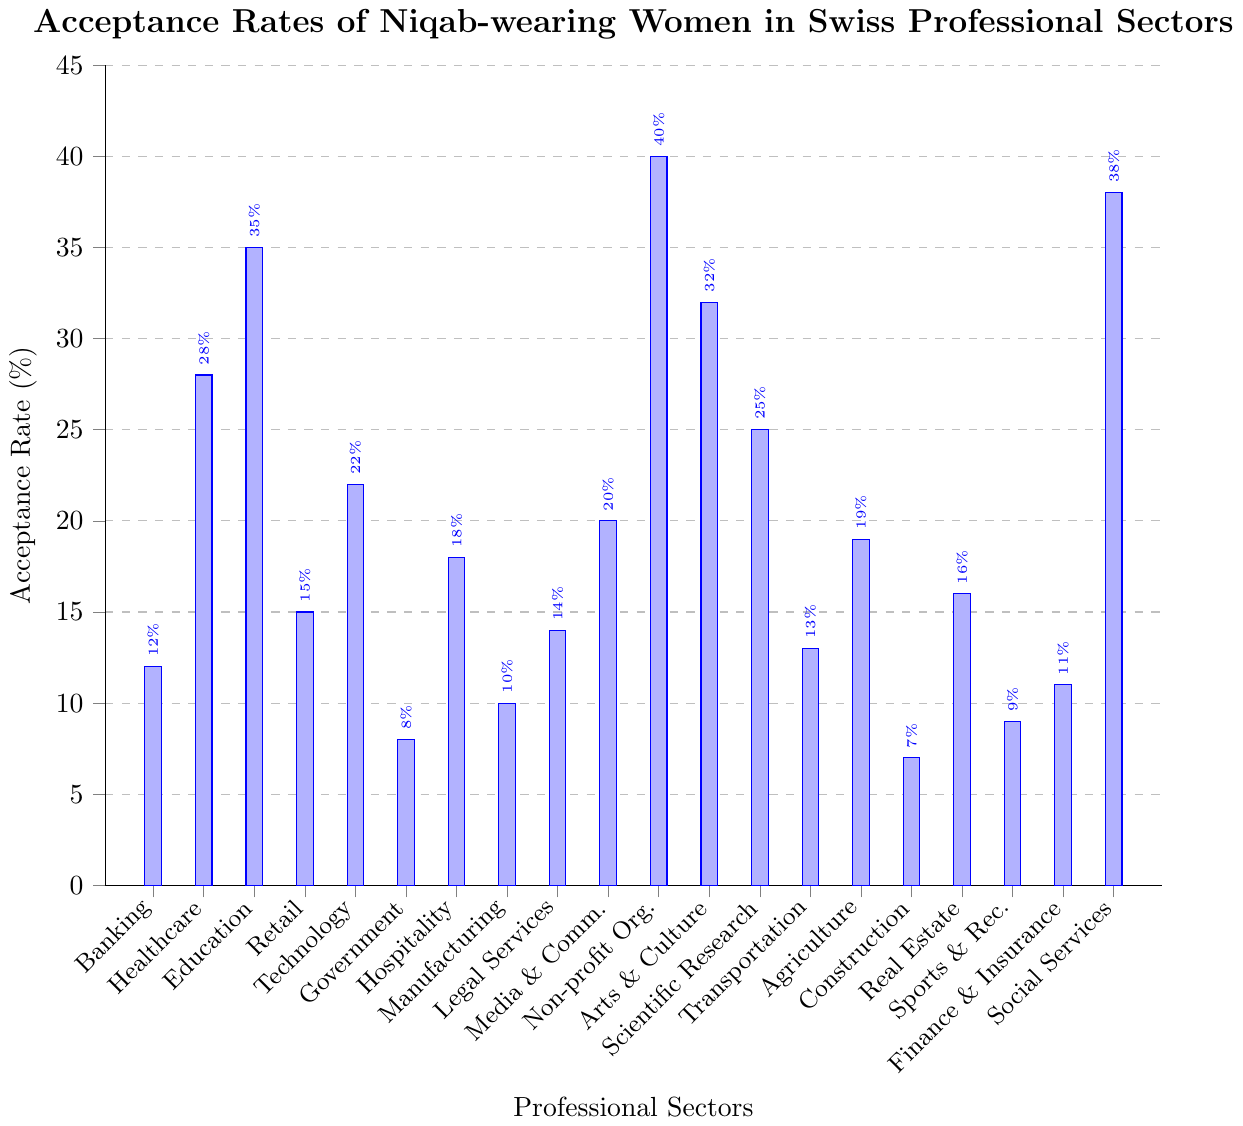What sector has the highest acceptance rate for Niqab-wearing women? Looking at the bar chart, we can see that the highest bar corresponds to the "Non-profit Organizations" sector, which has a value of 40%.
Answer: Non-profit Organizations Which sector has the lowest acceptance rate for Niqab-wearing women? Referring to the bar chart, the smallest bar represents the "Construction" sector with an acceptance rate of 7%.
Answer: Construction How does the acceptance rate in the Healthcare sector compare to that in the Technology sector? The bar chart shows that the acceptance rate for Healthcare is 28%, whereas for Technology it is 22%. Therefore, Healthcare has a higher acceptance rate than Technology.
Answer: Healthcare has a higher acceptance rate than Technology What is the total acceptance rate for Niqab-wearing women in the Banking, Retail, and Legal Services sectors combined? From the bar chart, the acceptance rates for Banking, Retail, and Legal Services are 12%, 15%, and 14%, respectively. Adding these up: 12 + 15 + 14 = 41%.
Answer: 41% What is the average acceptance rate for the Scientific Research, Transportation, and Agriculture sectors? The acceptance rates from the chart are 25% for Scientific Research, 13% for Transportation, and 19% for Agriculture. Adding these: 25 + 13 + 19 = 57. Dividing by 3: 57/3 = 19%.
Answer: 19% Which sector has a higher acceptance rate: Media and Communications or Arts and Culture? According to the chart, Media and Communications has an acceptance rate of 20%, while Arts and Culture has a rate of 32%. Therefore, Arts and Culture has a higher acceptance rate.
Answer: Arts and Culture How much more acceptance does the Education sector have compared to the Government sector? The chart shows that Education has an acceptance rate of 35%, and the Government sector has a rate of 8%. The difference is: 35 - 8 = 27%.
Answer: 27% What is the median acceptance rate among all the sectors shown in the bar chart? Listing the acceptance rates in ascending order: 7, 8, 9, 10, 11, 12, 13, 14, 15, 16, 18, 19, 20, 22, 25, 28, 32, 35, 38, 40. The median (middle value) among the 20 rates is the average of the 10th and 11th values: (16 + 18) / 2 = 17%.
Answer: 17% Identify two sectors with an acceptance rate close to 20% and specify their exact rates. Referring to the bar chart, the sectors "Media and Communications" and "Technology" have acceptance rates close to 20%, specifically at 20% and 22%, respectively.
Answer: Media and Communications (20%), Technology (22%) Which sectors have acceptance rates lower than 10%? From the bar chart, the sectors “Government”, “Construction”, and “Sports and Recreation” have acceptance rates lower than 10%, specifically at 8%, 7%, and 9%, respectively.
Answer: Government, Construction, Sports and Recreation 